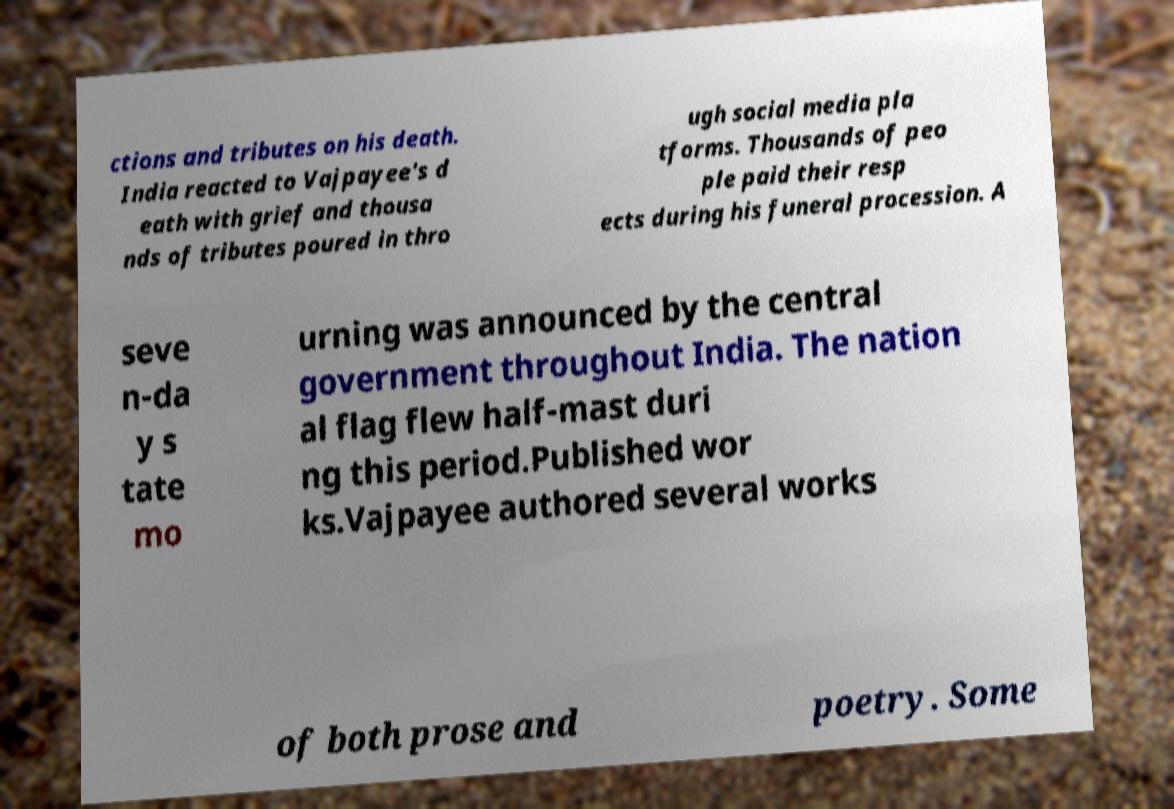For documentation purposes, I need the text within this image transcribed. Could you provide that? ctions and tributes on his death. India reacted to Vajpayee's d eath with grief and thousa nds of tributes poured in thro ugh social media pla tforms. Thousands of peo ple paid their resp ects during his funeral procession. A seve n-da y s tate mo urning was announced by the central government throughout India. The nation al flag flew half-mast duri ng this period.Published wor ks.Vajpayee authored several works of both prose and poetry. Some 